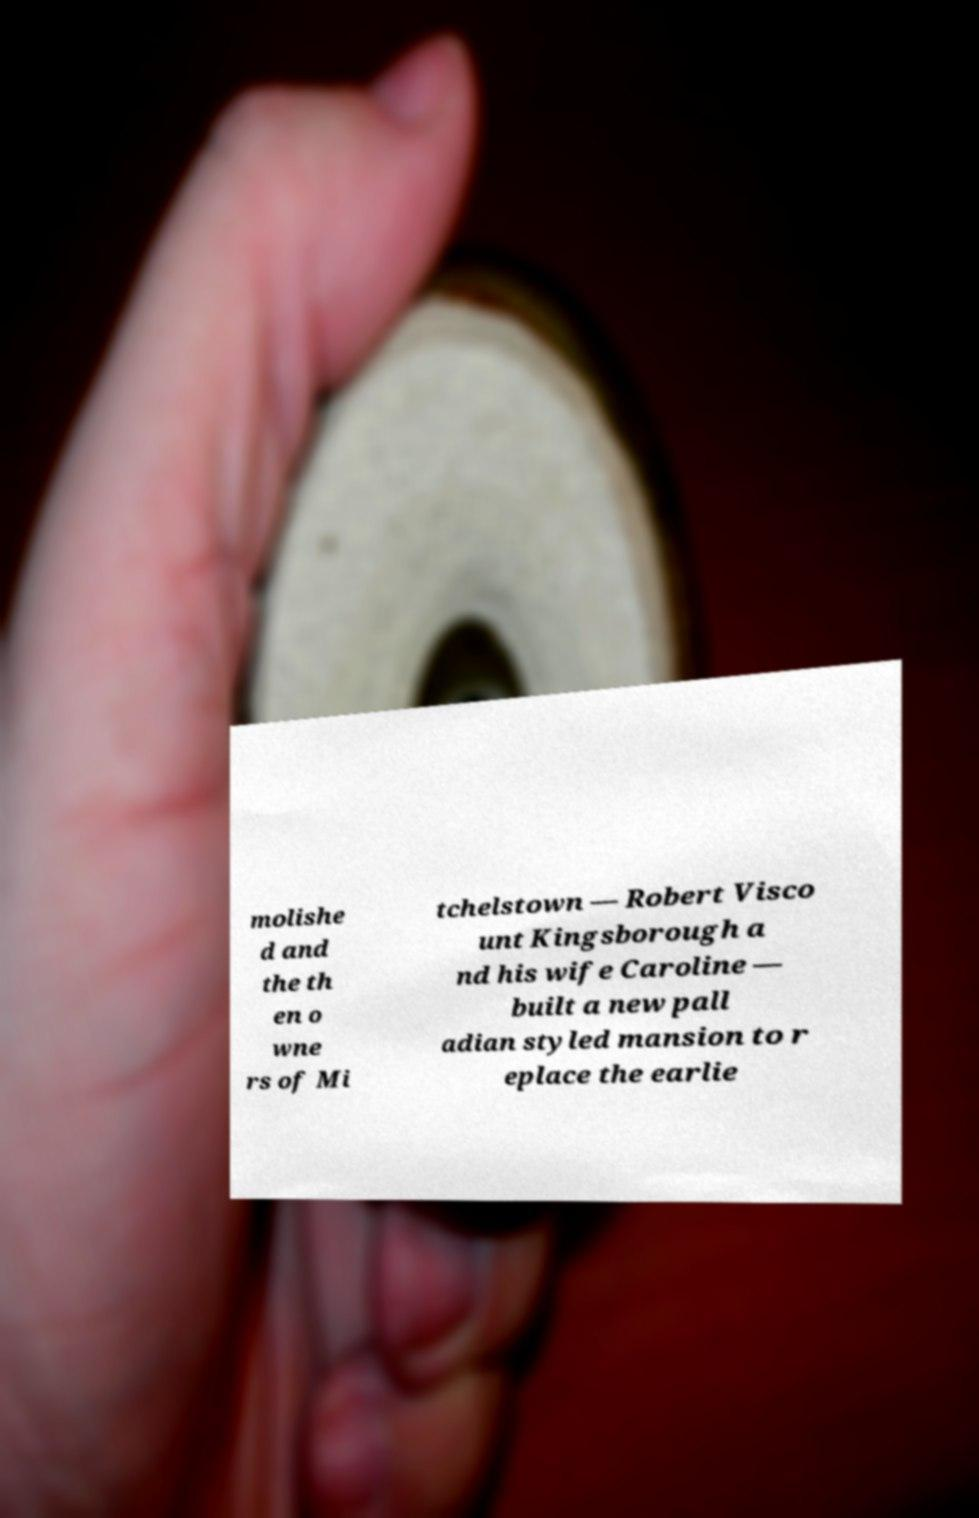What messages or text are displayed in this image? I need them in a readable, typed format. molishe d and the th en o wne rs of Mi tchelstown — Robert Visco unt Kingsborough a nd his wife Caroline — built a new pall adian styled mansion to r eplace the earlie 